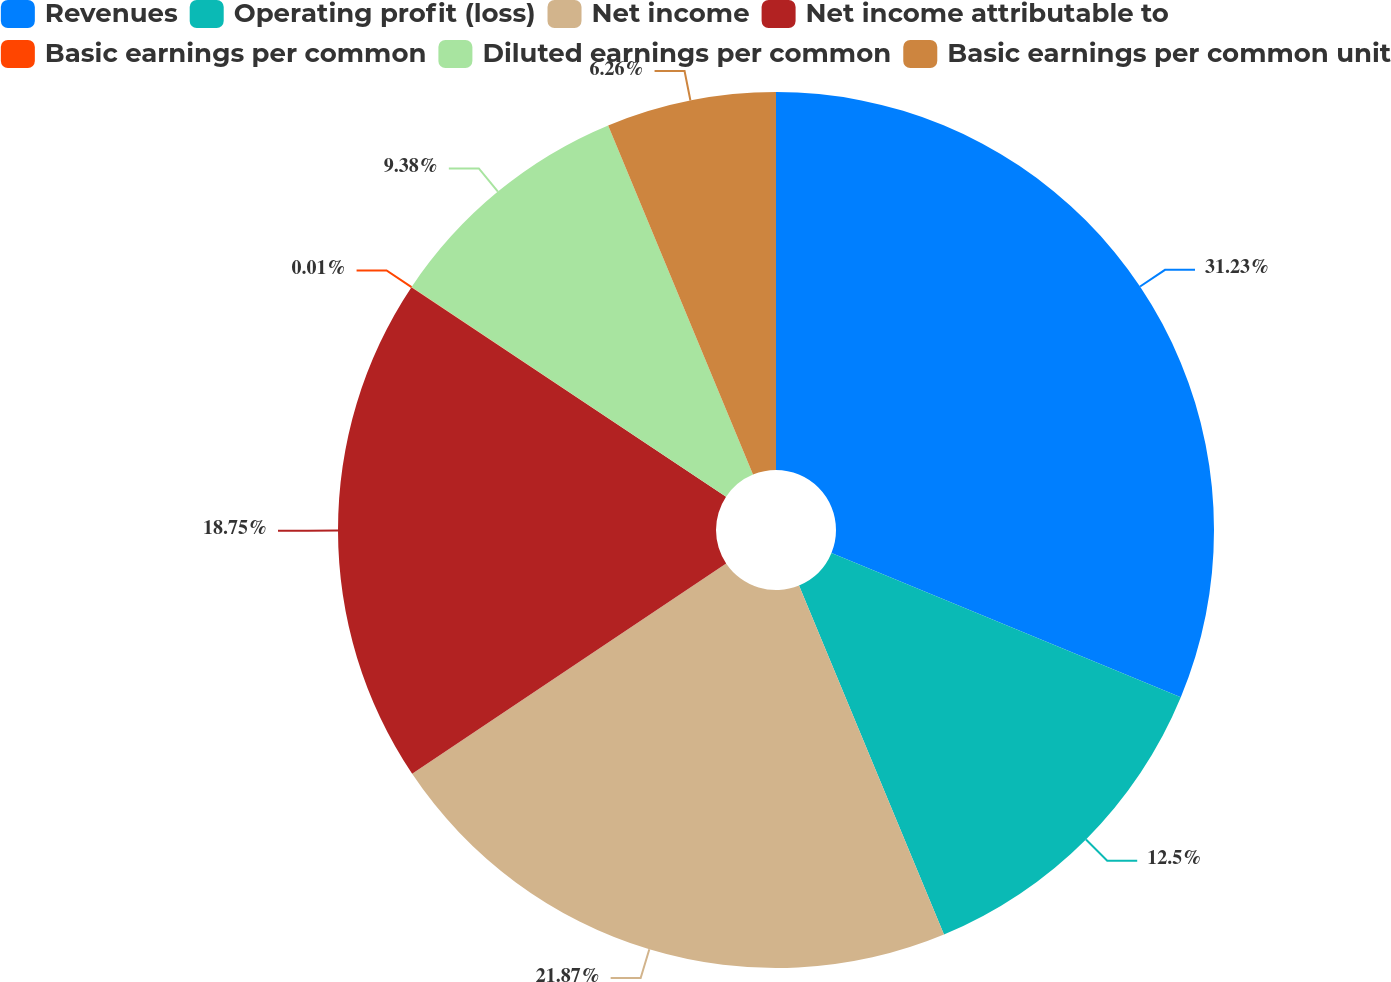<chart> <loc_0><loc_0><loc_500><loc_500><pie_chart><fcel>Revenues<fcel>Operating profit (loss)<fcel>Net income<fcel>Net income attributable to<fcel>Basic earnings per common<fcel>Diluted earnings per common<fcel>Basic earnings per common unit<nl><fcel>31.24%<fcel>12.5%<fcel>21.87%<fcel>18.75%<fcel>0.01%<fcel>9.38%<fcel>6.26%<nl></chart> 